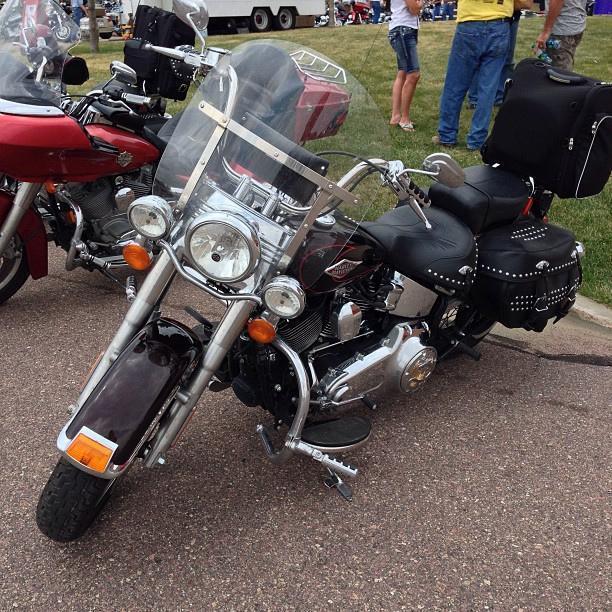Why is the man holding plastic bottles?
Answer the question by selecting the correct answer among the 4 following choices and explain your choice with a short sentence. The answer should be formatted with the following format: `Answer: choice
Rationale: rationale.`
Options: To throw, to drink, to juggle, to sell. Answer: to drink.
Rationale: He wants a drink. 